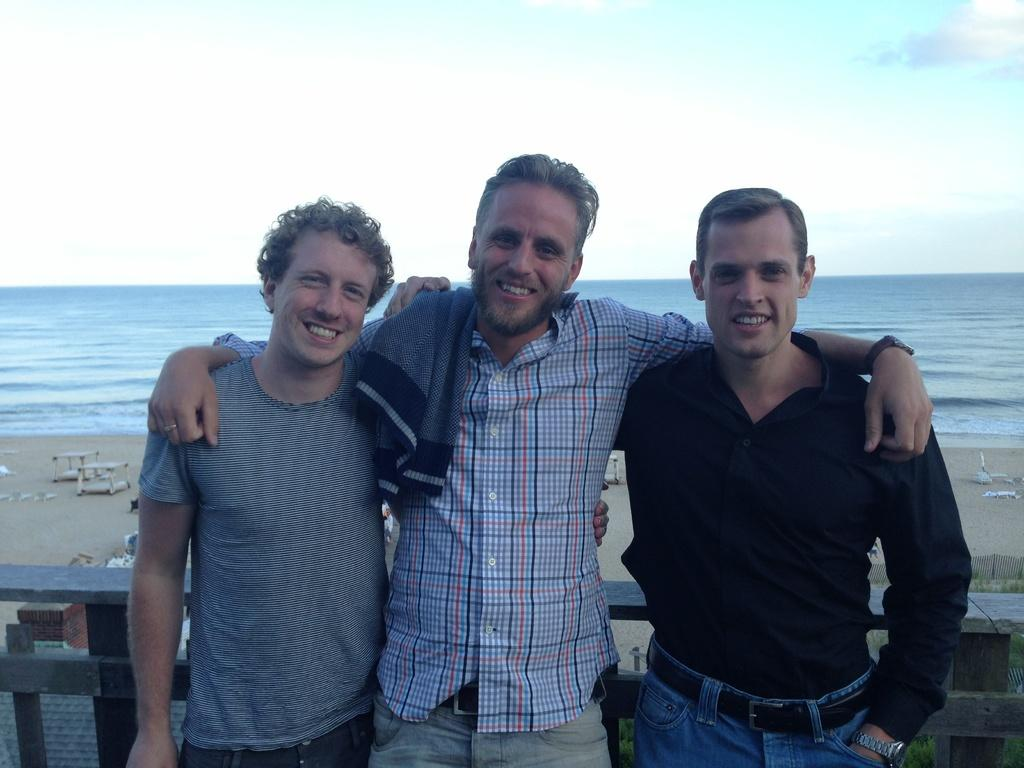What is the main subject of the image? There is a man standing in the middle of the image. What is the man wearing? The man is wearing a shirt and trousers. Are there any other people in the image? Yes, there are two other men standing beside the first man. What is the setting of the image? The scene takes place near a beach. What can be seen at the top of the image? The sky is visible at the top of the image. Where is the skate located in the image? There is: There is no skate present in the image. What type of mailbox can be seen near the beach in the image? There is no mailbox visible in the image; it takes place near a beach, but no mailbox is mentioned in the facts provided. 